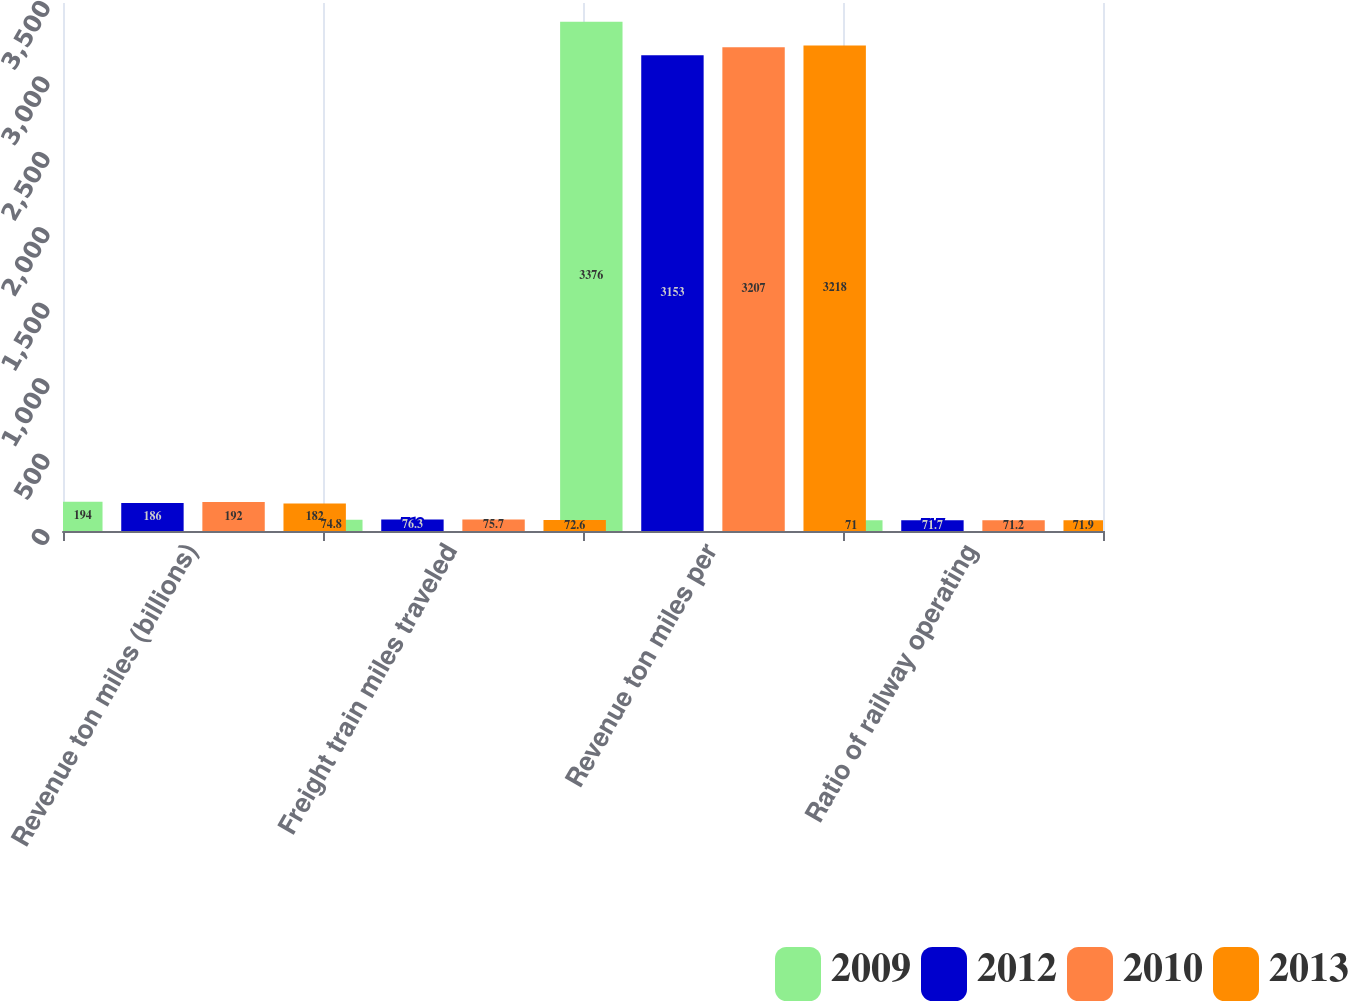Convert chart. <chart><loc_0><loc_0><loc_500><loc_500><stacked_bar_chart><ecel><fcel>Revenue ton miles (billions)<fcel>Freight train miles traveled<fcel>Revenue ton miles per<fcel>Ratio of railway operating<nl><fcel>2009<fcel>194<fcel>74.8<fcel>3376<fcel>71<nl><fcel>2012<fcel>186<fcel>76.3<fcel>3153<fcel>71.7<nl><fcel>2010<fcel>192<fcel>75.7<fcel>3207<fcel>71.2<nl><fcel>2013<fcel>182<fcel>72.6<fcel>3218<fcel>71.9<nl></chart> 